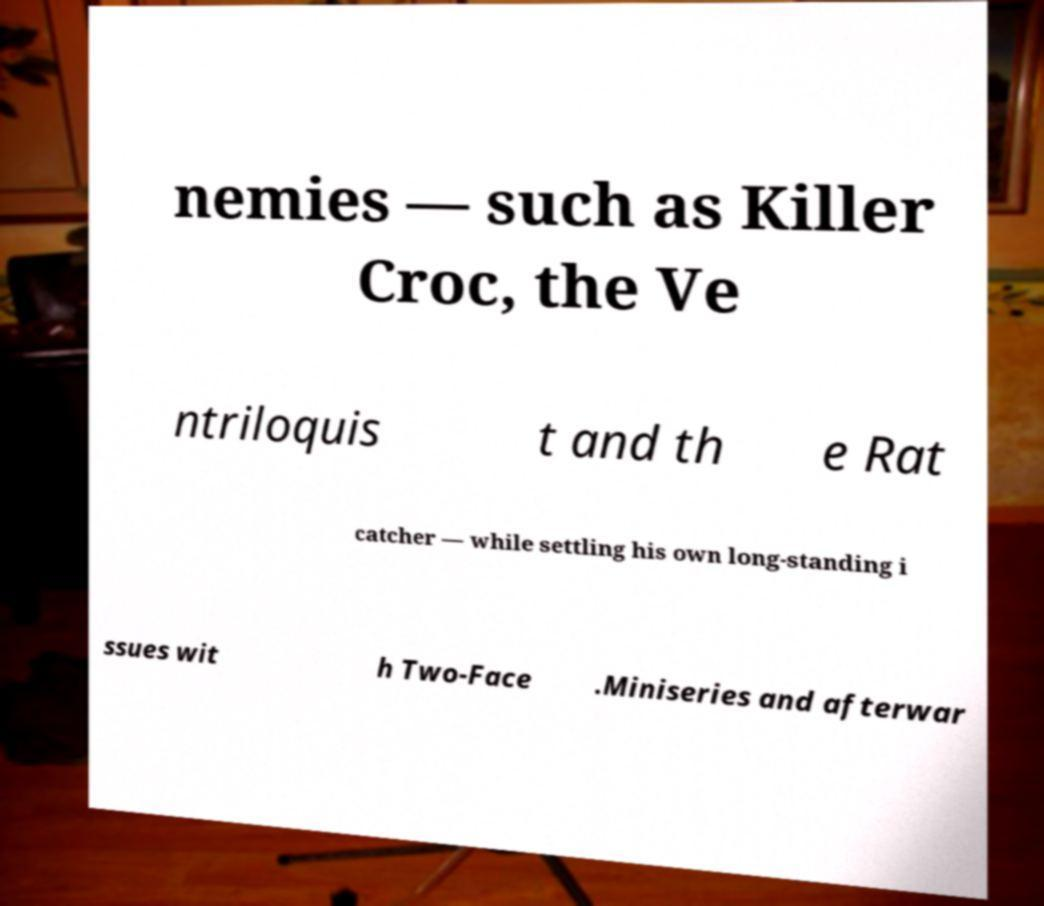Could you extract and type out the text from this image? nemies — such as Killer Croc, the Ve ntriloquis t and th e Rat catcher — while settling his own long-standing i ssues wit h Two-Face .Miniseries and afterwar 